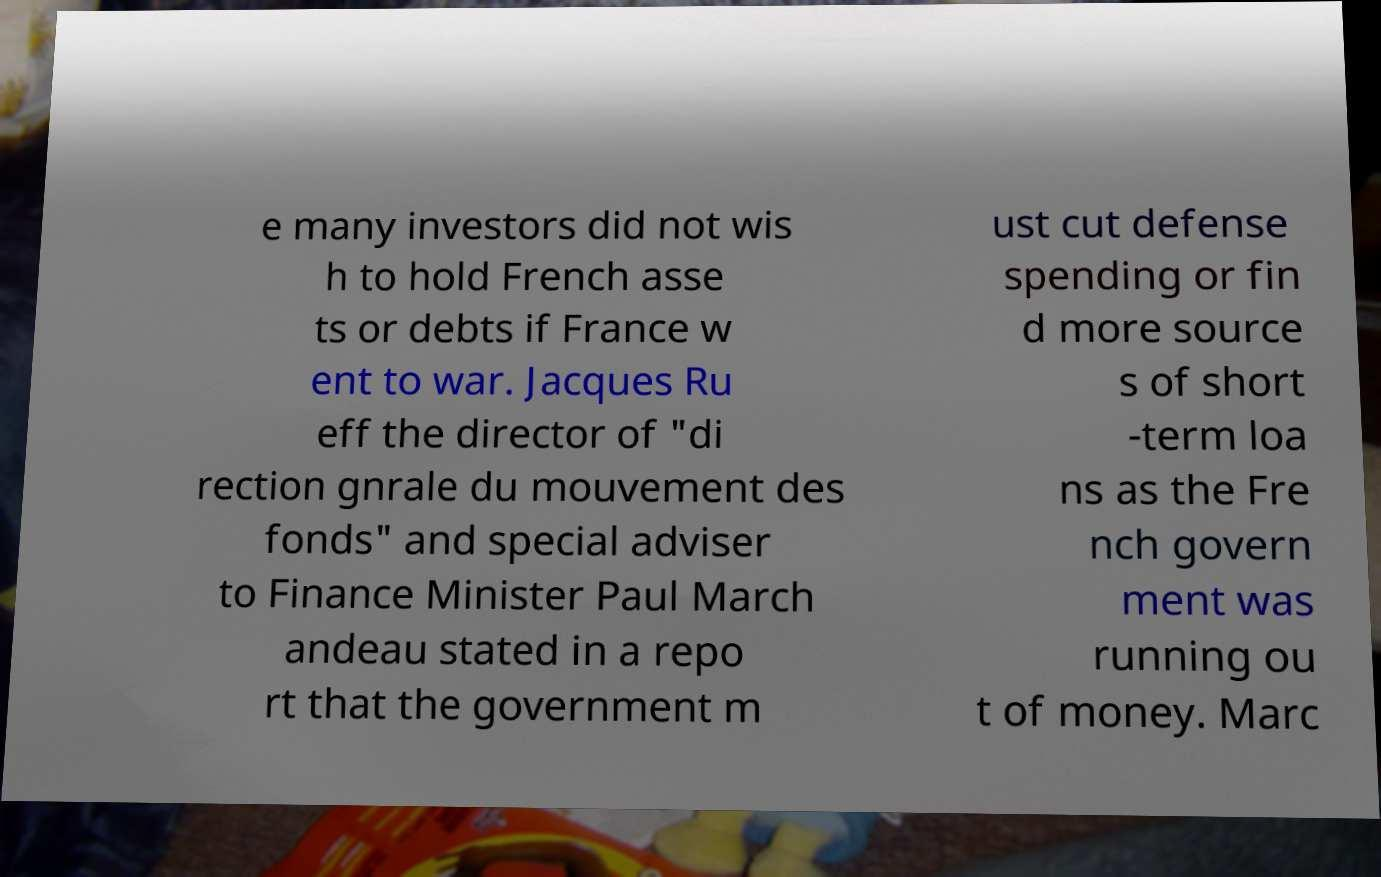What messages or text are displayed in this image? I need them in a readable, typed format. e many investors did not wis h to hold French asse ts or debts if France w ent to war. Jacques Ru eff the director of "di rection gnrale du mouvement des fonds" and special adviser to Finance Minister Paul March andeau stated in a repo rt that the government m ust cut defense spending or fin d more source s of short -term loa ns as the Fre nch govern ment was running ou t of money. Marc 